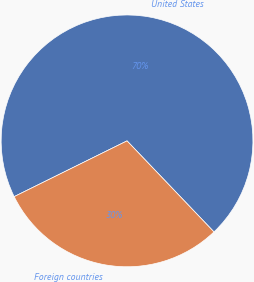Convert chart to OTSL. <chart><loc_0><loc_0><loc_500><loc_500><pie_chart><fcel>United States<fcel>Foreign countries<nl><fcel>70.17%<fcel>29.83%<nl></chart> 